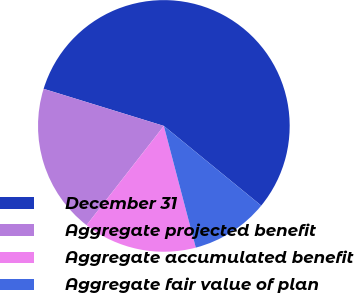Convert chart to OTSL. <chart><loc_0><loc_0><loc_500><loc_500><pie_chart><fcel>December 31<fcel>Aggregate projected benefit<fcel>Aggregate accumulated benefit<fcel>Aggregate fair value of plan<nl><fcel>56.15%<fcel>19.23%<fcel>14.62%<fcel>10.0%<nl></chart> 